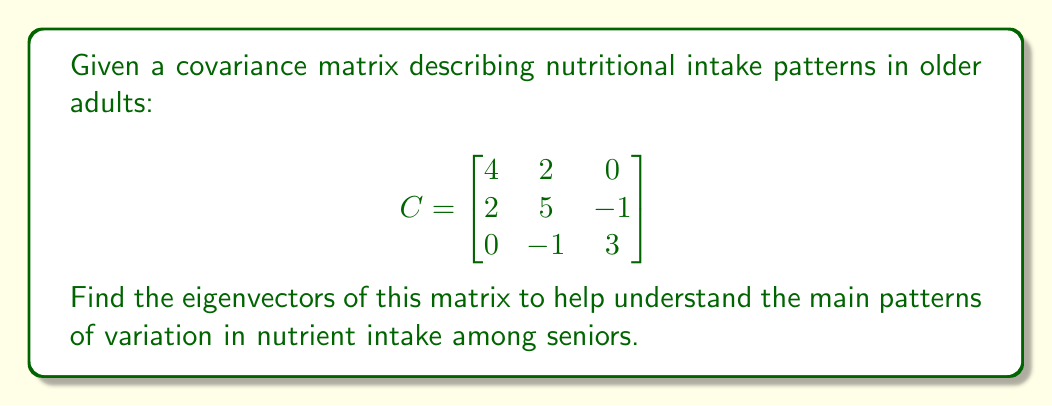What is the answer to this math problem? To find the eigenvectors of the covariance matrix C, we follow these steps:

1) First, we need to find the eigenvalues by solving the characteristic equation:
   $det(C - \lambda I) = 0$

2) Expand the determinant:
   $$\begin{vmatrix}
   4-\lambda & 2 & 0 \\
   2 & 5-\lambda & -1 \\
   0 & -1 & 3-\lambda
   \end{vmatrix} = 0$$

3) Solve the resulting cubic equation:
   $(4-\lambda)(5-\lambda)(3-\lambda) - 2(2)(3-\lambda) - (-1)^2(4-\lambda) = 0$
   $\lambda^3 - 12\lambda^2 + 41\lambda - 38 = 0$

4) The roots of this equation are the eigenvalues: $\lambda_1 = 2$, $\lambda_2 = 3$, $\lambda_3 = 7$

5) For each eigenvalue, we solve $(C - \lambda I)v = 0$ to find the corresponding eigenvector:

   For $\lambda_1 = 2$:
   $$\begin{bmatrix}
   2 & 2 & 0 \\
   2 & 3 & -1 \\
   0 & -1 & 1
   \end{bmatrix} \begin{bmatrix} v_1 \\ v_2 \\ v_3 \end{bmatrix} = \begin{bmatrix} 0 \\ 0 \\ 0 \end{bmatrix}$$
   Solving this gives: $v_1 = [-1, 1, 1]^T$

   For $\lambda_2 = 3$:
   $$\begin{bmatrix}
   1 & 2 & 0 \\
   2 & 2 & -1 \\
   0 & -1 & 0
   \end{bmatrix} \begin{bmatrix} v_1 \\ v_2 \\ v_3 \end{bmatrix} = \begin{bmatrix} 0 \\ 0 \\ 0 \end{bmatrix}$$
   Solving this gives: $v_2 = [0, 1, 2]^T$

   For $\lambda_3 = 7$:
   $$\begin{bmatrix}
   -3 & 2 & 0 \\
   2 & -2 & -1 \\
   0 & -1 & -4
   \end{bmatrix} \begin{bmatrix} v_1 \\ v_2 \\ v_3 \end{bmatrix} = \begin{bmatrix} 0 \\ 0 \\ 0 \end{bmatrix}$$
   Solving this gives: $v_3 = [2, 3, -1]^T$

6) Normalize each eigenvector to unit length.
Answer: $v_1 = \frac{1}{\sqrt{3}}[-1, 1, 1]^T$, $v_2 = \frac{1}{\sqrt{5}}[0, 1, 2]^T$, $v_3 = \frac{1}{\sqrt{14}}[2, 3, -1]^T$ 